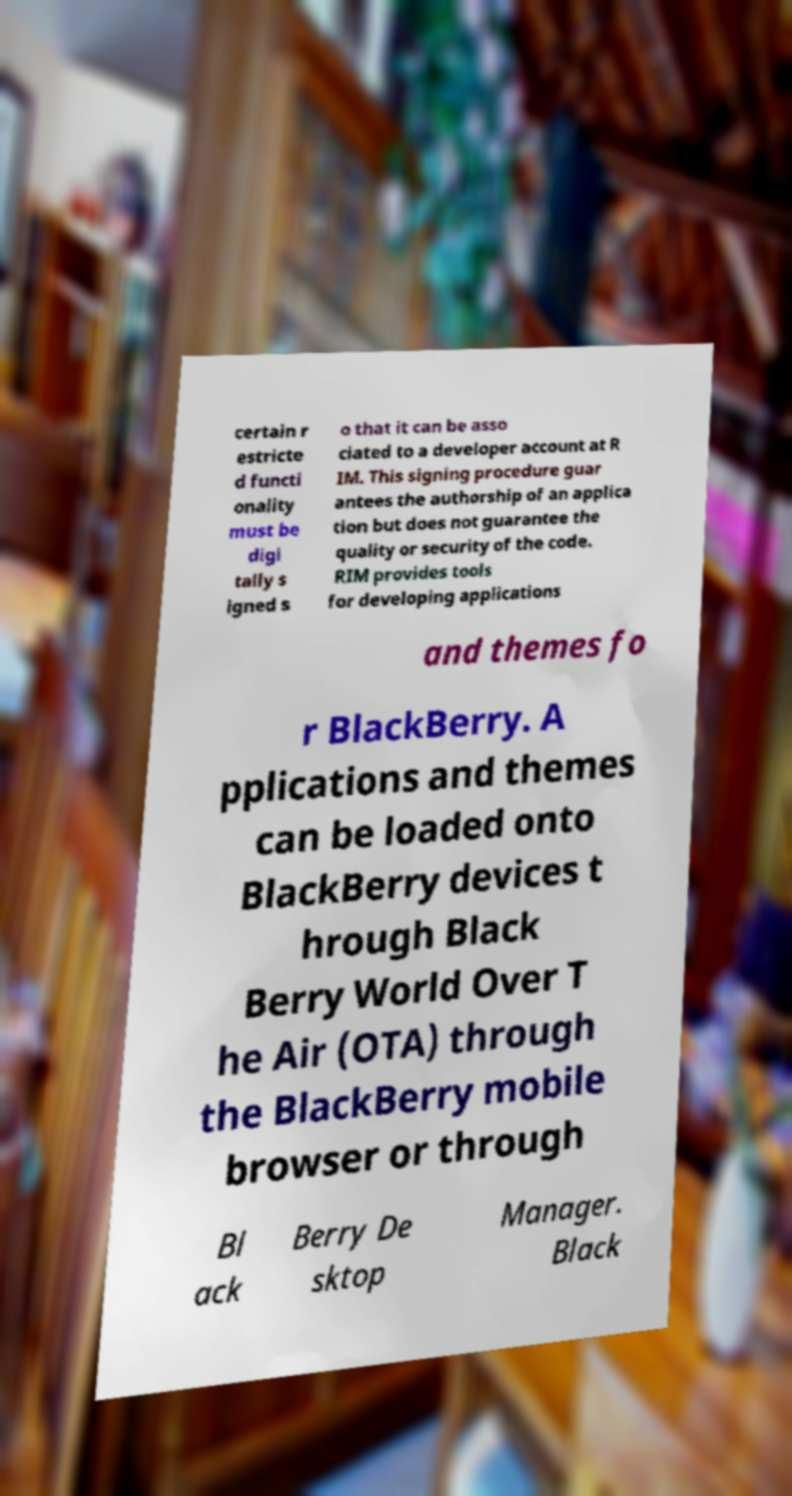I need the written content from this picture converted into text. Can you do that? certain r estricte d functi onality must be digi tally s igned s o that it can be asso ciated to a developer account at R IM. This signing procedure guar antees the authorship of an applica tion but does not guarantee the quality or security of the code. RIM provides tools for developing applications and themes fo r BlackBerry. A pplications and themes can be loaded onto BlackBerry devices t hrough Black Berry World Over T he Air (OTA) through the BlackBerry mobile browser or through Bl ack Berry De sktop Manager. Black 